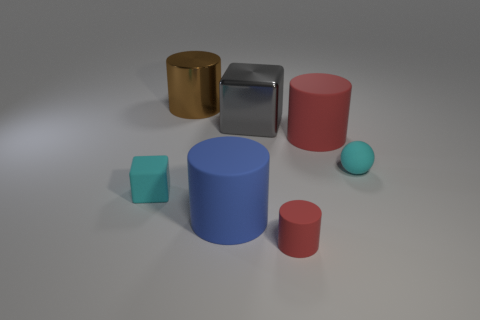There is a object that is the same color as the small rubber ball; what is its size?
Offer a terse response. Small. What shape is the rubber thing that is the same color as the sphere?
Provide a succinct answer. Cube. How big is the cyan object that is on the left side of the cylinder that is behind the matte cylinder behind the cyan rubber cube?
Keep it short and to the point. Small. What is the material of the blue object?
Offer a terse response. Rubber. Is the material of the blue thing the same as the block right of the big brown shiny cylinder?
Your response must be concise. No. Is there any other thing that has the same color as the rubber ball?
Offer a terse response. Yes. There is a big rubber cylinder to the left of the large gray metallic thing behind the big blue cylinder; is there a blue thing in front of it?
Offer a very short reply. No. The large shiny cylinder has what color?
Give a very brief answer. Brown. There is a tiny cyan rubber cube; are there any small spheres left of it?
Provide a short and direct response. No. Does the big brown thing have the same shape as the small cyan thing that is in front of the tiny rubber sphere?
Offer a very short reply. No. 